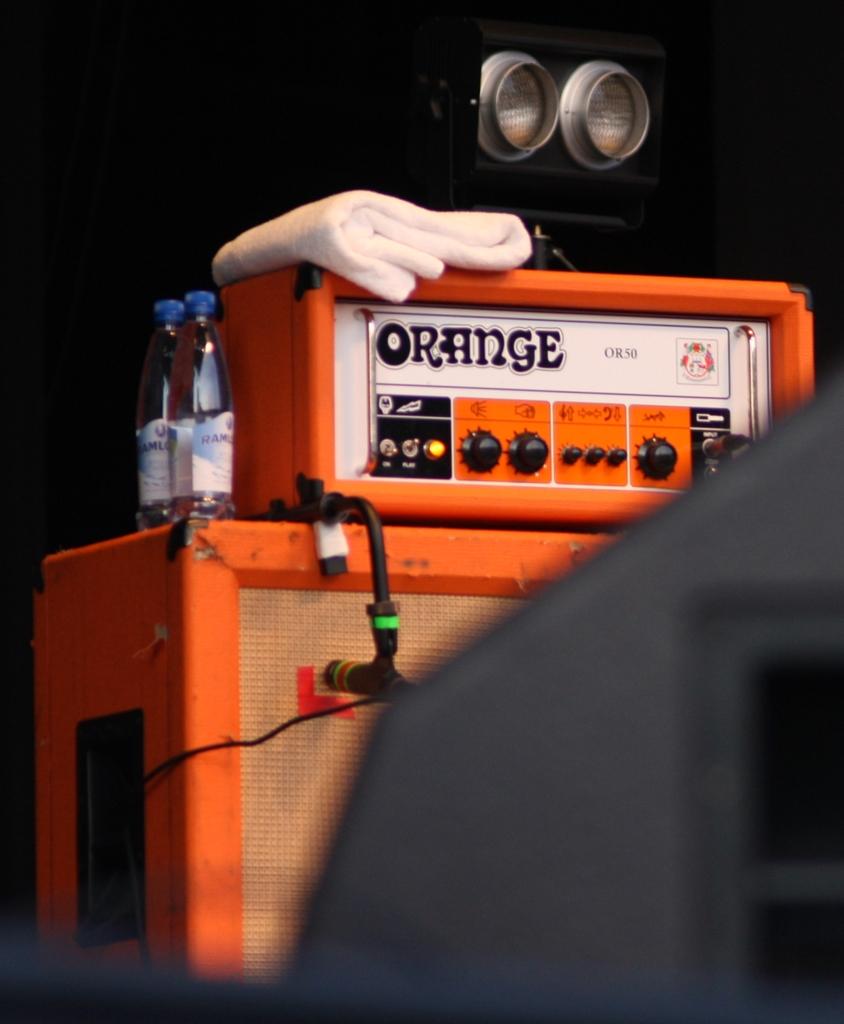What is the model number of this amp?
Provide a short and direct response. Or50. 